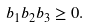Convert formula to latex. <formula><loc_0><loc_0><loc_500><loc_500>b _ { 1 } b _ { 2 } b _ { 3 } \geq 0 .</formula> 